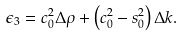<formula> <loc_0><loc_0><loc_500><loc_500>\epsilon _ { 3 } = c _ { 0 } ^ { 2 } \Delta \rho + \left ( c _ { 0 } ^ { 2 } - s _ { 0 } ^ { 2 } \right ) \Delta k .</formula> 